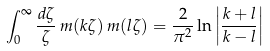Convert formula to latex. <formula><loc_0><loc_0><loc_500><loc_500>\int _ { 0 } ^ { \infty } \frac { d \zeta } { \zeta } \, m ( k \zeta ) \, m ( l \zeta ) = \frac { 2 } { \pi ^ { 2 } } \ln \left | \frac { k + l } { k - l } \right |</formula> 